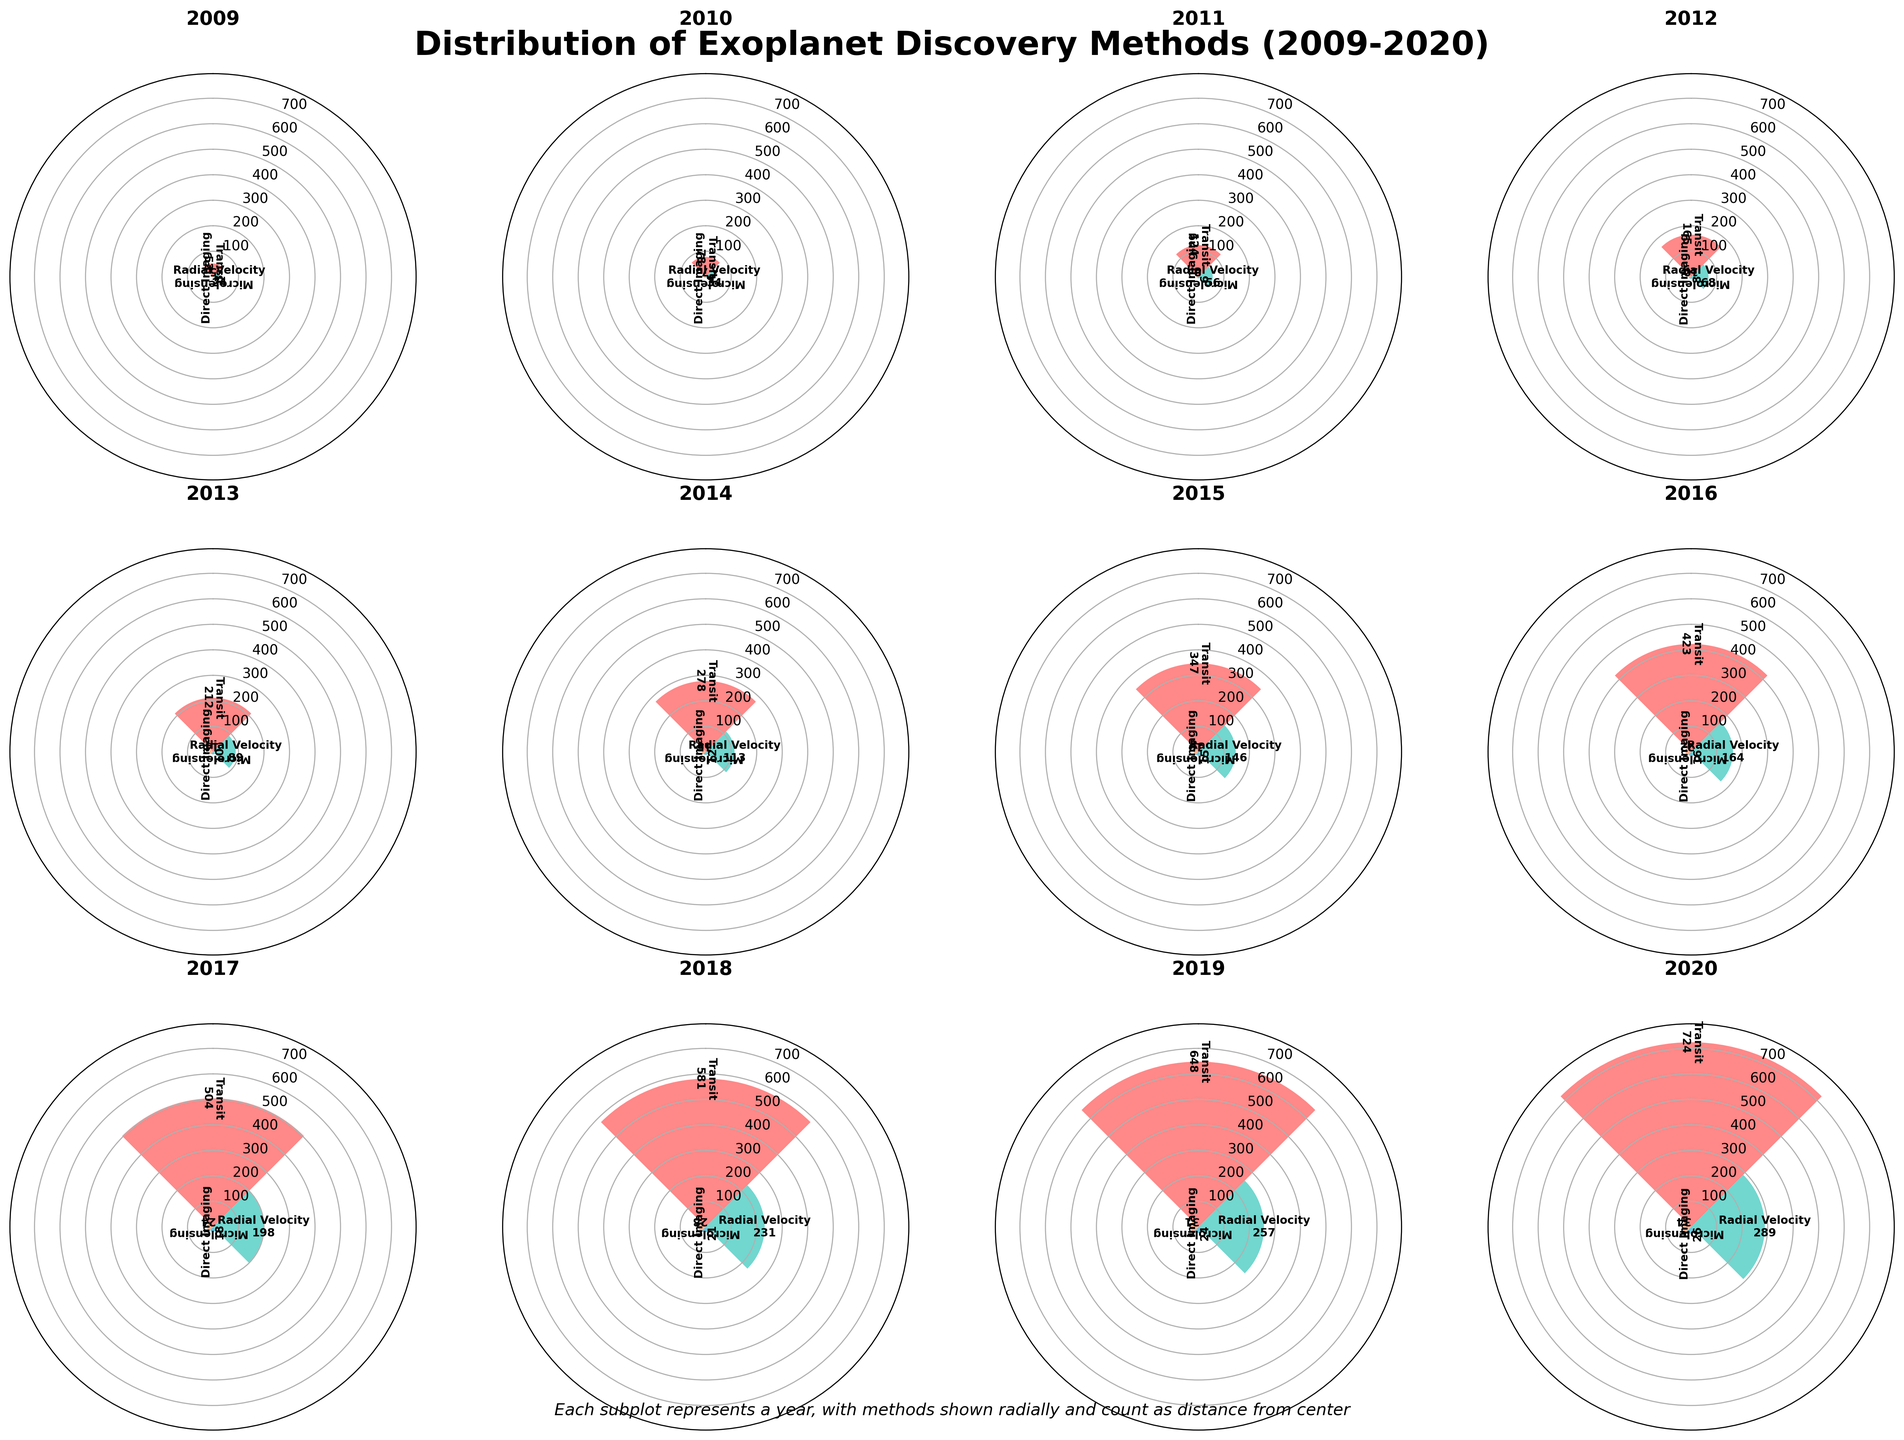What is the title of the figure? The title of the figure is prominently displayed at the top, stating the topic of the data.
Answer: Distribution of Exoplanet Discovery Methods (2009-2020) Which year had the highest number of exoplanet discoveries using the Transit method? Look at the radial distance for the specific segment labeled 'Transit' across all subplots. Identify the subplot with the largest segment for Transit.
Answer: 2020 How do the discovery counts using Direct Imaging in 2010 and 2015 compare? For the years 2010 and 2015, compare the length of the segments labeled 'Direct Imaging.' Identify which year has a larger or smaller segment.
Answer: 2015 had more discoveries than 2010 In which year did the Microlensing method start exceeding 20 discoveries? Look for the first year where the Microlensing segment extends beyond the radial marker for 20 discoveries.
Answer: 2016 What is the total number of exoplanet discoveries in 2017 across all methods? Add the counts of all discovery methods for the year 2017.
Answer: 504+198+18+24 = 744 Which discovery method showed the most consistent increase in the number of discoveries over the years? Examine all methods and evaluate which consistently has increasing radial distances across the years.
Answer: Transit How do the counts for Radial Velocity discoveries in 2019 and 2020 compare? Compare the radial distances for Radial Velocity segments in the 2019 and 2020 subplots. Identify which has the longer segment.
Answer: 2020 has more discoveries than 2019 Which year had the smallest number of total exoplanet discoveries? Sum the segments for each year and identify the smallest total value.
Answer: 2009 What's the combined count of exoplanet discoveries using Direct Imaging and Microlensing in 2018? Add the counts of Direct Imaging and Microlensing for the year 2018.
Answer: 21 + 28 = 49 In how many years did Transit discoveries exceed 500? Examine each subplot and count the years where the Transit segment reaches beyond the 500 marker.
Answer: 2 Which discovery method had the lowest number of discoveries in 2012? Examine the four methods for the year 2012 and identify the one with the smallest segment.
Answer: Direct Imaging 